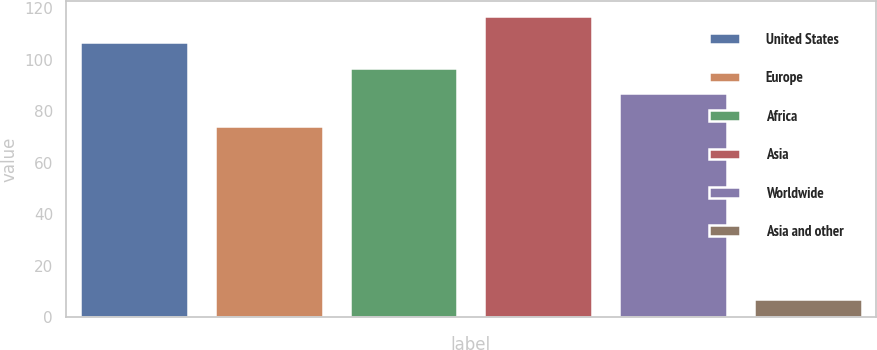<chart> <loc_0><loc_0><loc_500><loc_500><bar_chart><fcel>United States<fcel>Europe<fcel>Africa<fcel>Asia<fcel>Worldwide<fcel>Asia and other<nl><fcel>107.06<fcel>74.14<fcel>97<fcel>117.12<fcel>86.94<fcel>6.9<nl></chart> 